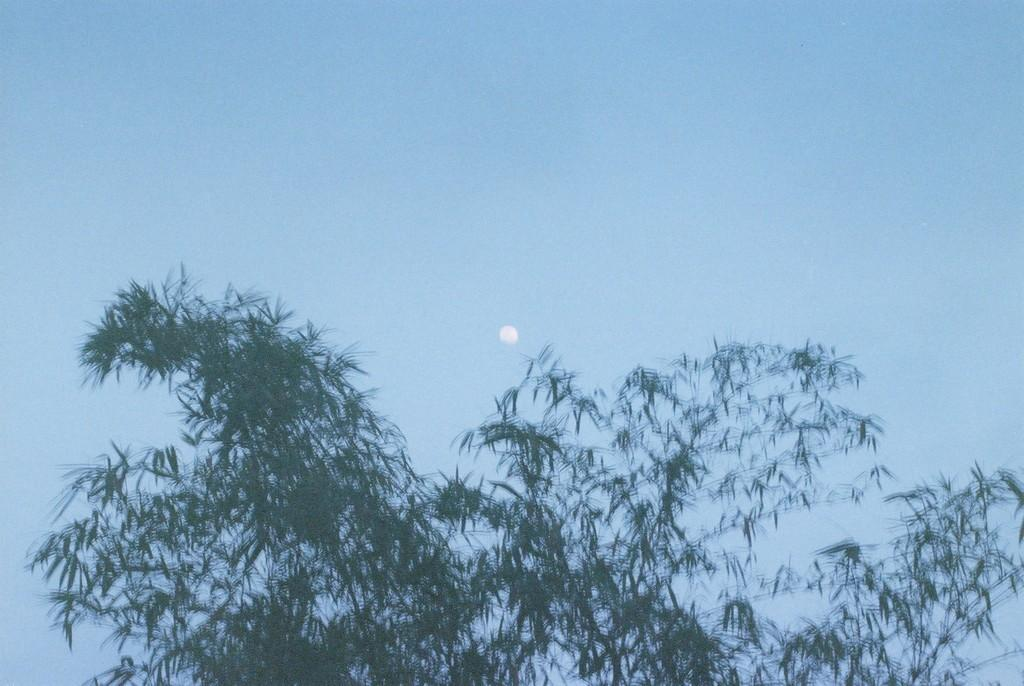What is located at the front of the image? There is a tree in the front of the image. What can be seen in the background of the image? There is a blue sky visible in the background of the image. What type of throat is visible in the image? There is no throat present in the image; it features a tree and a blue sky. What shape is the hall in the image? There is no hall present in the image; it only features a tree and a blue sky. 